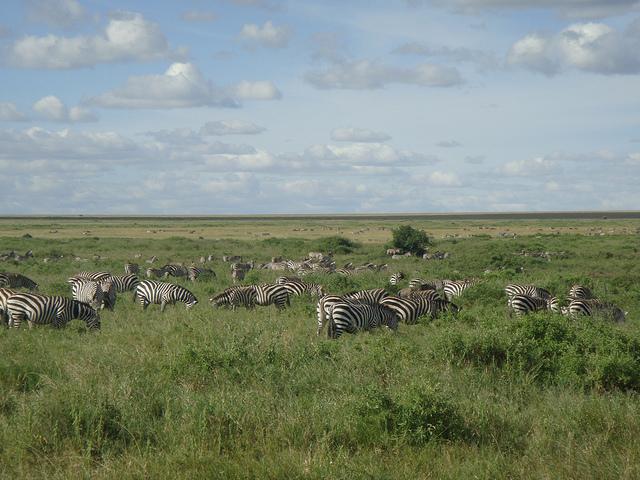Are the Zebras in their natural habitat?
Short answer required. Yes. How many animals are in the picture?
Short answer required. 30. How many zebras are there?
Quick response, please. 40. What type of land are the zebras on?
Quick response, please. Grassland. Can you see a large body of water in the background of this picture?
Keep it brief. No. How many zebra's are there?
Write a very short answer. Lot. What country are the zebras in?
Write a very short answer. Africa. What color is the grass?
Quick response, please. Green. What plants are in the picture?
Short answer required. Grass. What is in the far background?
Write a very short answer. Grass. Who is in the picture with the animals?
Concise answer only. No one. Are these a herd of zebras?
Short answer required. Yes. 